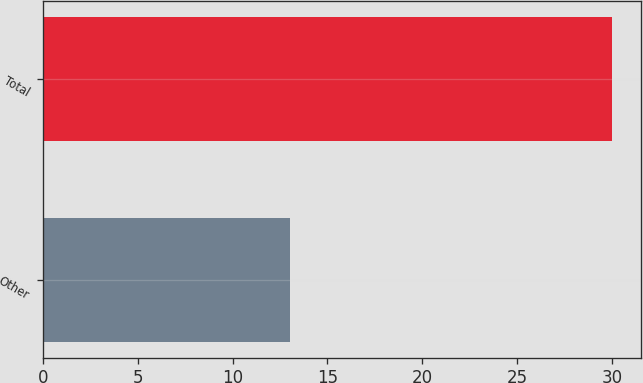Convert chart. <chart><loc_0><loc_0><loc_500><loc_500><bar_chart><fcel>Other<fcel>Total<nl><fcel>13<fcel>30<nl></chart> 